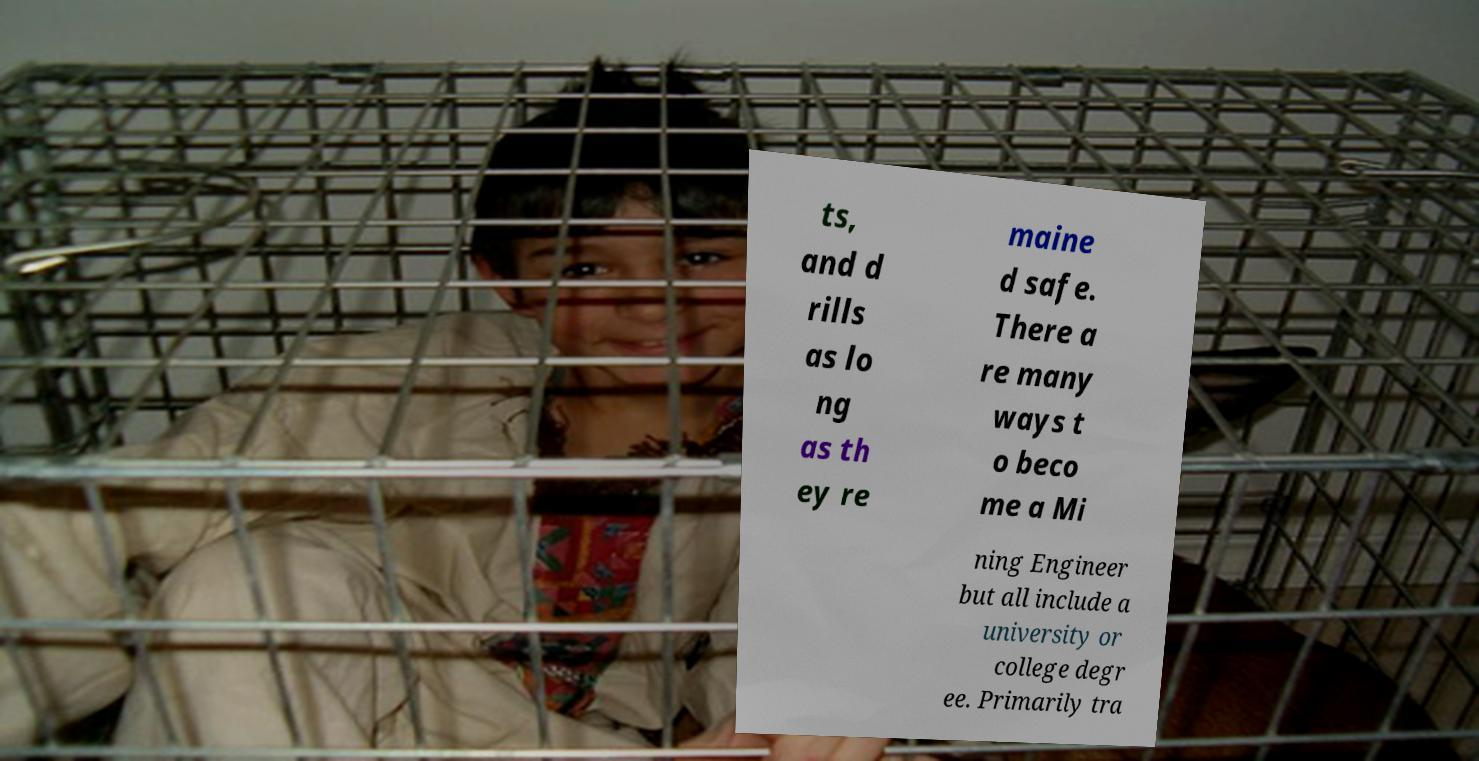For documentation purposes, I need the text within this image transcribed. Could you provide that? ts, and d rills as lo ng as th ey re maine d safe. There a re many ways t o beco me a Mi ning Engineer but all include a university or college degr ee. Primarily tra 